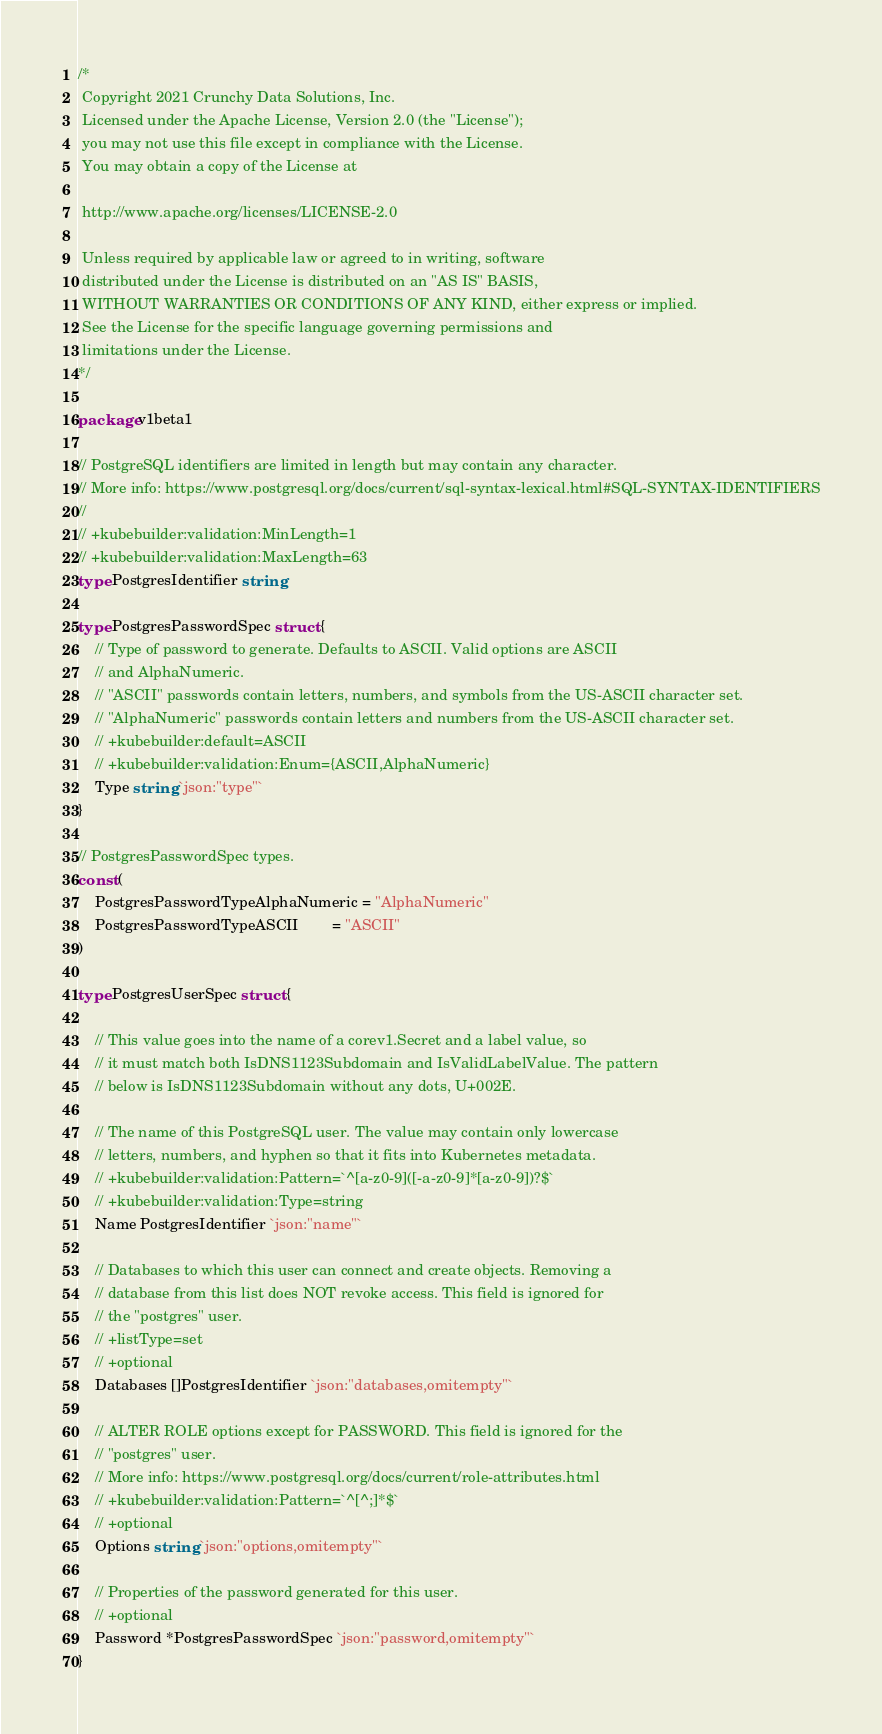<code> <loc_0><loc_0><loc_500><loc_500><_Go_>/*
 Copyright 2021 Crunchy Data Solutions, Inc.
 Licensed under the Apache License, Version 2.0 (the "License");
 you may not use this file except in compliance with the License.
 You may obtain a copy of the License at

 http://www.apache.org/licenses/LICENSE-2.0

 Unless required by applicable law or agreed to in writing, software
 distributed under the License is distributed on an "AS IS" BASIS,
 WITHOUT WARRANTIES OR CONDITIONS OF ANY KIND, either express or implied.
 See the License for the specific language governing permissions and
 limitations under the License.
*/

package v1beta1

// PostgreSQL identifiers are limited in length but may contain any character.
// More info: https://www.postgresql.org/docs/current/sql-syntax-lexical.html#SQL-SYNTAX-IDENTIFIERS
//
// +kubebuilder:validation:MinLength=1
// +kubebuilder:validation:MaxLength=63
type PostgresIdentifier string

type PostgresPasswordSpec struct {
	// Type of password to generate. Defaults to ASCII. Valid options are ASCII
	// and AlphaNumeric.
	// "ASCII" passwords contain letters, numbers, and symbols from the US-ASCII character set.
	// "AlphaNumeric" passwords contain letters and numbers from the US-ASCII character set.
	// +kubebuilder:default=ASCII
	// +kubebuilder:validation:Enum={ASCII,AlphaNumeric}
	Type string `json:"type"`
}

// PostgresPasswordSpec types.
const (
	PostgresPasswordTypeAlphaNumeric = "AlphaNumeric"
	PostgresPasswordTypeASCII        = "ASCII"
)

type PostgresUserSpec struct {

	// This value goes into the name of a corev1.Secret and a label value, so
	// it must match both IsDNS1123Subdomain and IsValidLabelValue. The pattern
	// below is IsDNS1123Subdomain without any dots, U+002E.

	// The name of this PostgreSQL user. The value may contain only lowercase
	// letters, numbers, and hyphen so that it fits into Kubernetes metadata.
	// +kubebuilder:validation:Pattern=`^[a-z0-9]([-a-z0-9]*[a-z0-9])?$`
	// +kubebuilder:validation:Type=string
	Name PostgresIdentifier `json:"name"`

	// Databases to which this user can connect and create objects. Removing a
	// database from this list does NOT revoke access. This field is ignored for
	// the "postgres" user.
	// +listType=set
	// +optional
	Databases []PostgresIdentifier `json:"databases,omitempty"`

	// ALTER ROLE options except for PASSWORD. This field is ignored for the
	// "postgres" user.
	// More info: https://www.postgresql.org/docs/current/role-attributes.html
	// +kubebuilder:validation:Pattern=`^[^;]*$`
	// +optional
	Options string `json:"options,omitempty"`

	// Properties of the password generated for this user.
	// +optional
	Password *PostgresPasswordSpec `json:"password,omitempty"`
}
</code> 